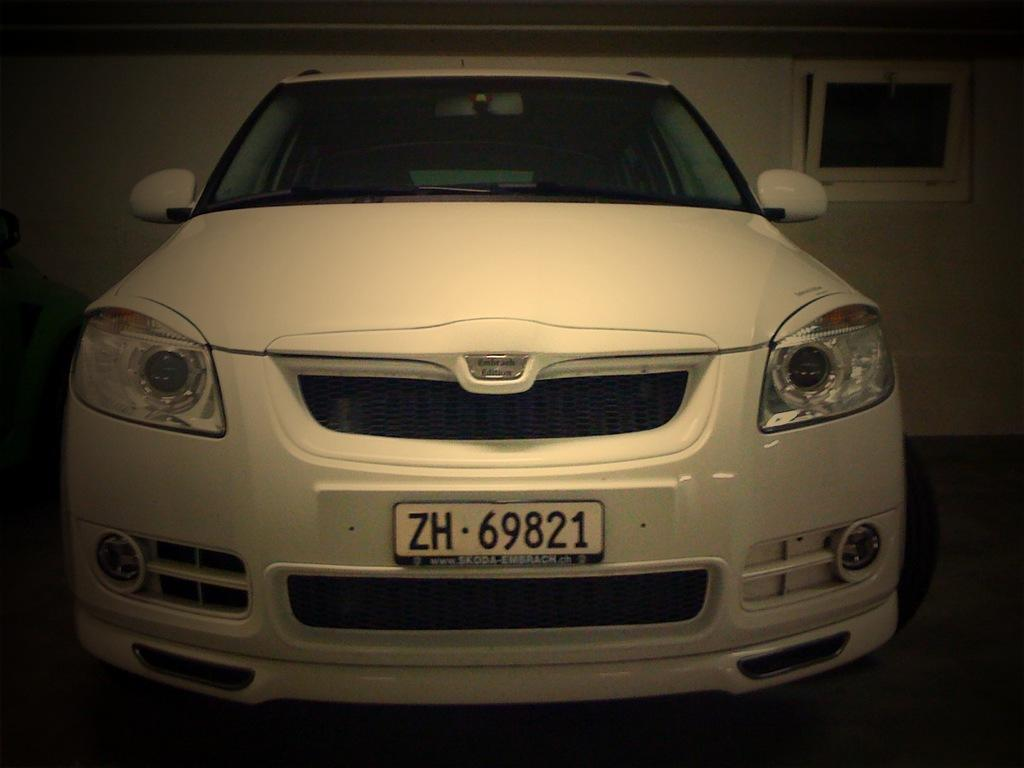What is the main subject of the image? The main subject of the image is a car. What else can be seen in the image besides the car? There is a wall and a window in the image. How many bears are sitting on the car in the image? There are no bears present in the image; it only features a car, a wall, and a window. 